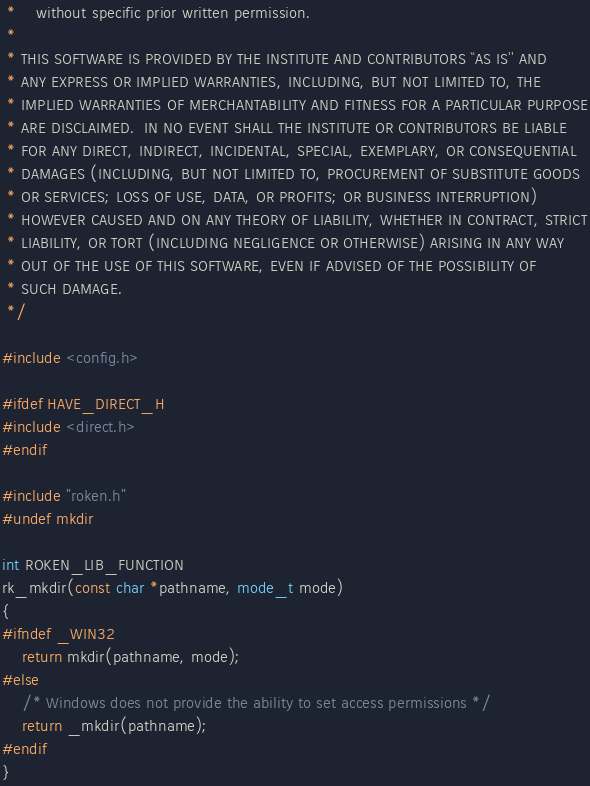<code> <loc_0><loc_0><loc_500><loc_500><_C_> *    without specific prior written permission.
 *
 * THIS SOFTWARE IS PROVIDED BY THE INSTITUTE AND CONTRIBUTORS ``AS IS'' AND
 * ANY EXPRESS OR IMPLIED WARRANTIES, INCLUDING, BUT NOT LIMITED TO, THE
 * IMPLIED WARRANTIES OF MERCHANTABILITY AND FITNESS FOR A PARTICULAR PURPOSE
 * ARE DISCLAIMED.  IN NO EVENT SHALL THE INSTITUTE OR CONTRIBUTORS BE LIABLE
 * FOR ANY DIRECT, INDIRECT, INCIDENTAL, SPECIAL, EXEMPLARY, OR CONSEQUENTIAL
 * DAMAGES (INCLUDING, BUT NOT LIMITED TO, PROCUREMENT OF SUBSTITUTE GOODS
 * OR SERVICES; LOSS OF USE, DATA, OR PROFITS; OR BUSINESS INTERRUPTION)
 * HOWEVER CAUSED AND ON ANY THEORY OF LIABILITY, WHETHER IN CONTRACT, STRICT
 * LIABILITY, OR TORT (INCLUDING NEGLIGENCE OR OTHERWISE) ARISING IN ANY WAY
 * OUT OF THE USE OF THIS SOFTWARE, EVEN IF ADVISED OF THE POSSIBILITY OF
 * SUCH DAMAGE.
 */

#include <config.h>

#ifdef HAVE_DIRECT_H
#include <direct.h>
#endif

#include "roken.h"
#undef mkdir

int ROKEN_LIB_FUNCTION
rk_mkdir(const char *pathname, mode_t mode)
{
#ifndef _WIN32
    return mkdir(pathname, mode);
#else
    /* Windows does not provide the ability to set access permissions */
    return _mkdir(pathname);
#endif
}
</code> 